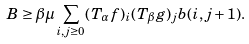Convert formula to latex. <formula><loc_0><loc_0><loc_500><loc_500>B & \geq \beta \mu \sum _ { i , j \geq 0 } ( T _ { \alpha } f ) _ { i } ( T _ { \beta } g ) _ { j } b ( i , j + 1 ) .</formula> 